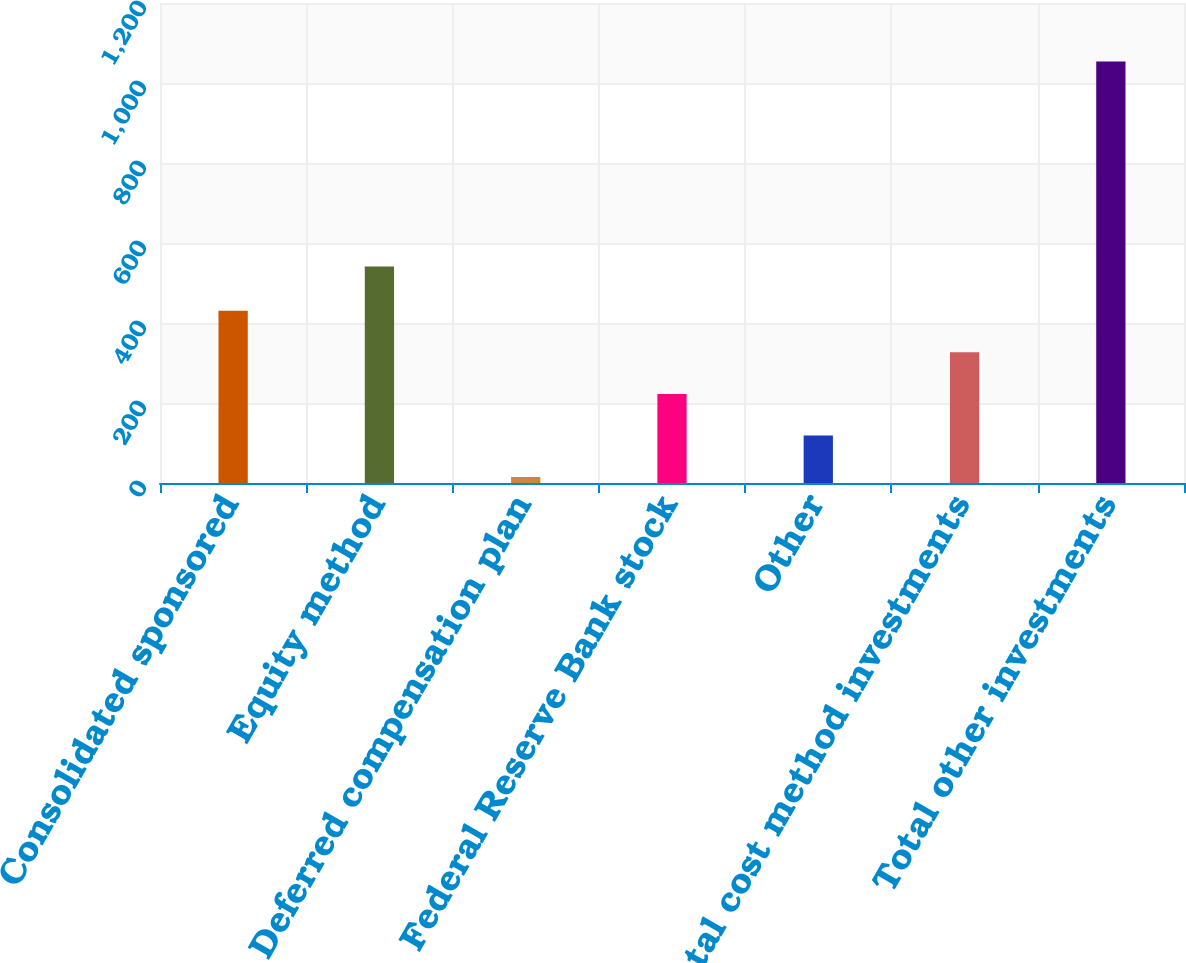<chart> <loc_0><loc_0><loc_500><loc_500><bar_chart><fcel>Consolidated sponsored<fcel>Equity method<fcel>Deferred compensation plan<fcel>Federal Reserve Bank stock<fcel>Other<fcel>Total cost method investments<fcel>Total other investments<nl><fcel>430.6<fcel>541<fcel>15<fcel>222.8<fcel>118.9<fcel>326.7<fcel>1054<nl></chart> 